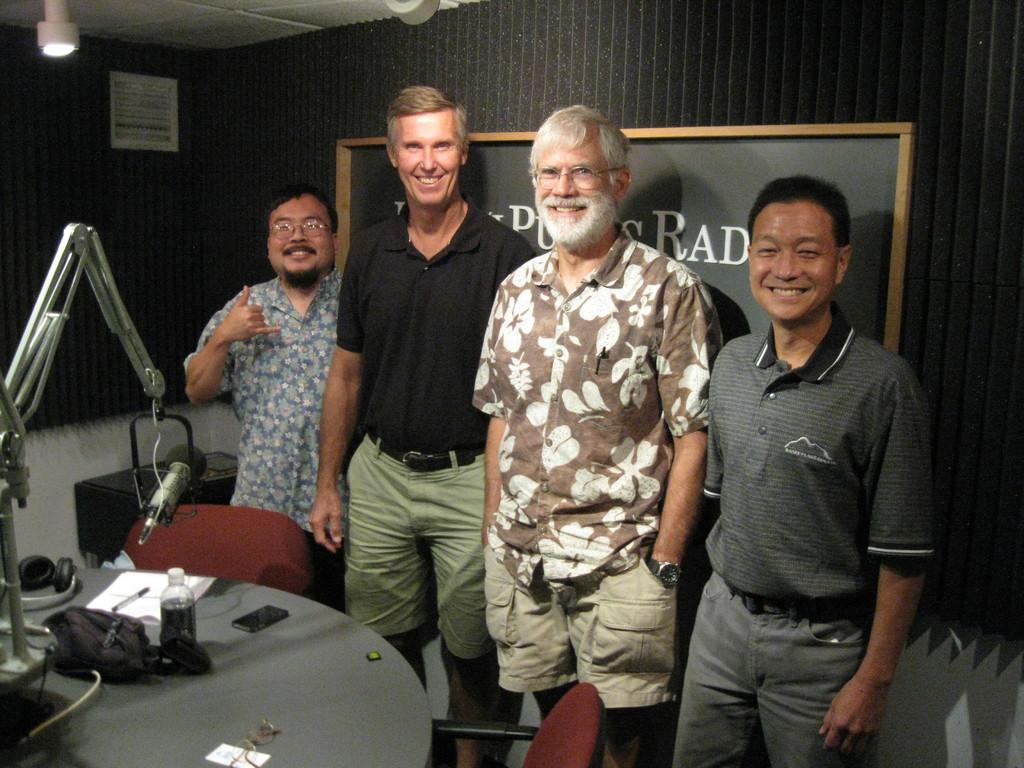How many people are in the image? There are four persons in the image. What are the people doing in the image? The four persons are standing in front of a mic. Where is the mic located in the image? The mic is placed on a table. What type of field can be seen in the background of the image? There is no field visible in the image; it only shows four persons standing in front of a mic placed on a table. 